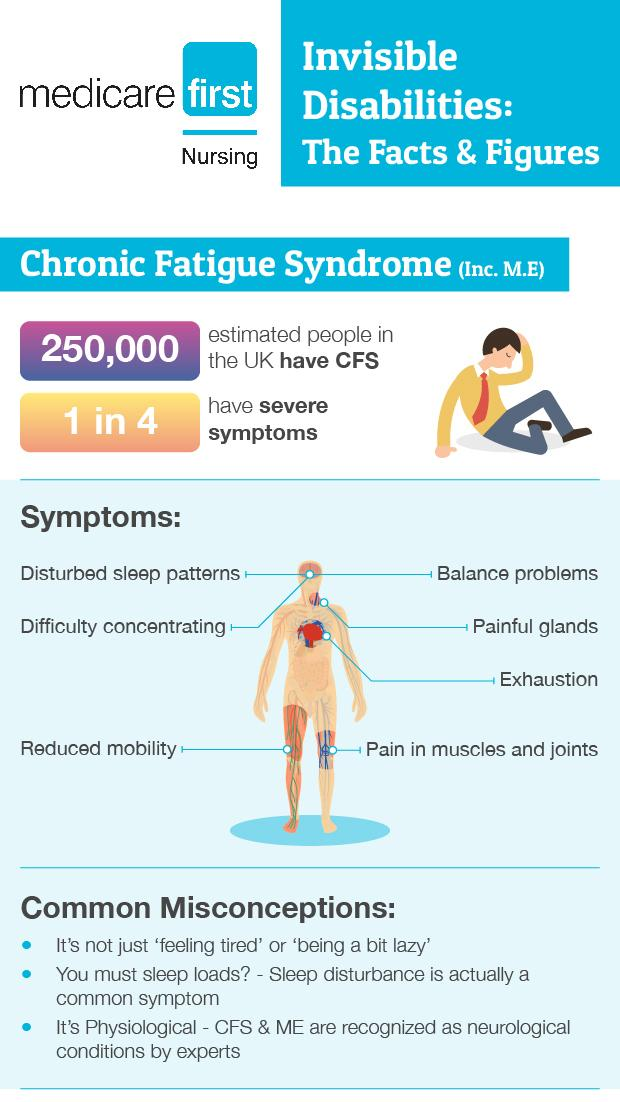Give some essential details in this illustration. According to the data, approximately 75% of people do not have severe symptoms. 